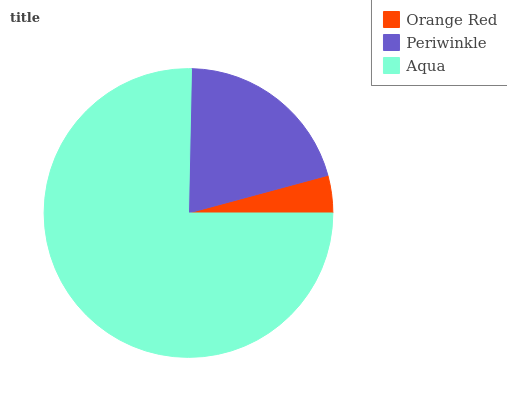Is Orange Red the minimum?
Answer yes or no. Yes. Is Aqua the maximum?
Answer yes or no. Yes. Is Periwinkle the minimum?
Answer yes or no. No. Is Periwinkle the maximum?
Answer yes or no. No. Is Periwinkle greater than Orange Red?
Answer yes or no. Yes. Is Orange Red less than Periwinkle?
Answer yes or no. Yes. Is Orange Red greater than Periwinkle?
Answer yes or no. No. Is Periwinkle less than Orange Red?
Answer yes or no. No. Is Periwinkle the high median?
Answer yes or no. Yes. Is Periwinkle the low median?
Answer yes or no. Yes. Is Aqua the high median?
Answer yes or no. No. Is Orange Red the low median?
Answer yes or no. No. 